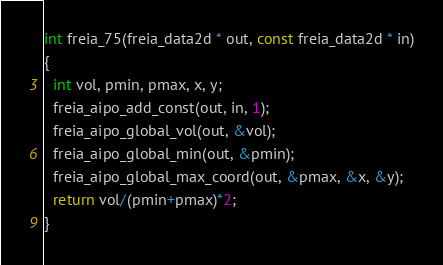Convert code to text. <code><loc_0><loc_0><loc_500><loc_500><_C_>
int freia_75(freia_data2d * out, const freia_data2d * in)
{
  int vol, pmin, pmax, x, y;
  freia_aipo_add_const(out, in, 1);
  freia_aipo_global_vol(out, &vol);
  freia_aipo_global_min(out, &pmin);
  freia_aipo_global_max_coord(out, &pmax, &x, &y);
  return vol/(pmin+pmax)*2;
}
</code> 